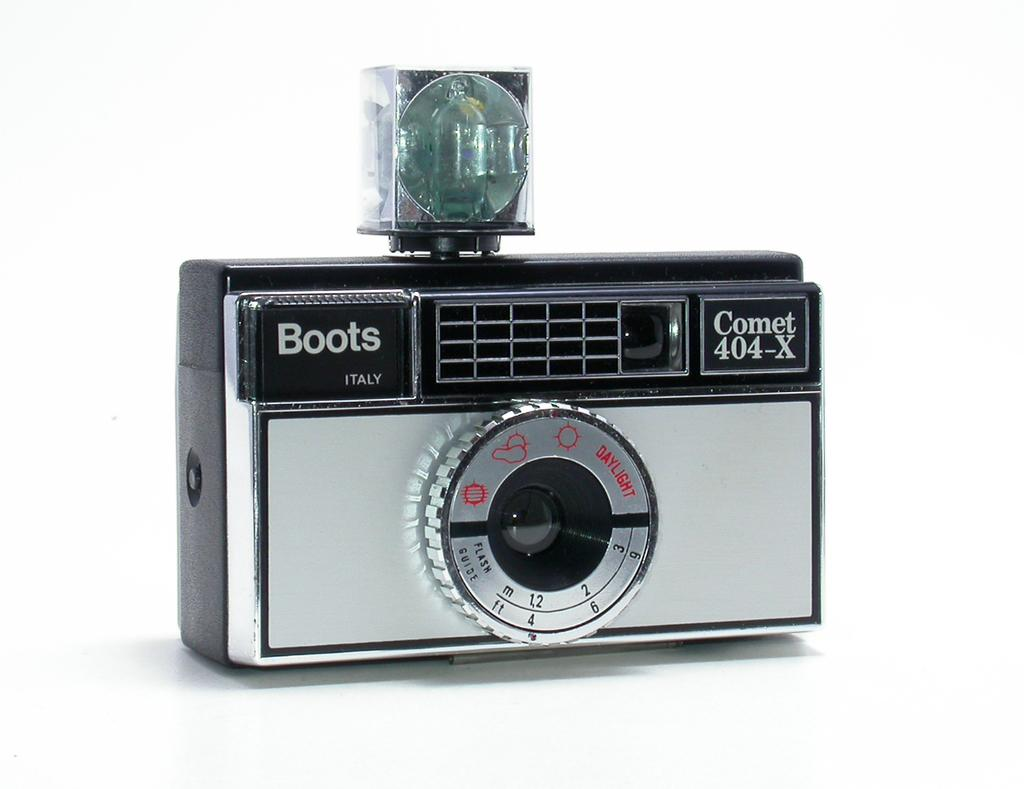What is the main subject in the center of the image? There is a camera in the center of the image. Are there any words written on the camera? Yes, the words "Boots Italy" are written on the camera. What type of liquid can be seen coming out of the camera in the image? There is no liquid coming out of the camera in the image. What is the camera's interest rate in the image? The camera does not have an interest rate, as it is a physical object and not a financial entity. 